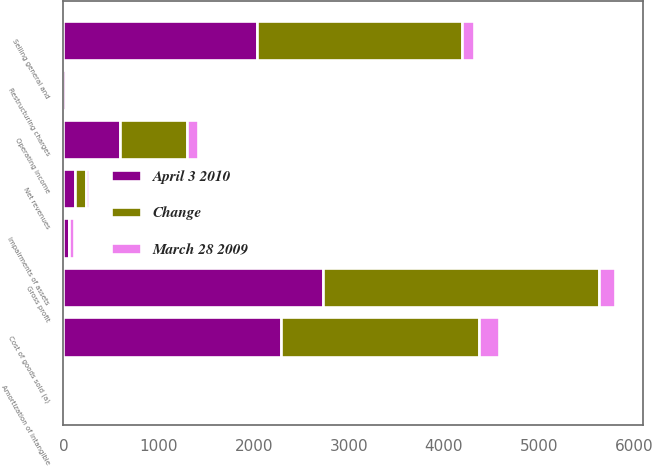<chart> <loc_0><loc_0><loc_500><loc_500><stacked_bar_chart><ecel><fcel>Net revenues<fcel>Cost of goods sold (a)<fcel>Gross profit<fcel>Selling general and<fcel>Amortization of intangible<fcel>Impairments of assets<fcel>Restructuring charges<fcel>Operating income<nl><fcel>Change<fcel>116.2<fcel>2079.8<fcel>2899.1<fcel>2157<fcel>21.7<fcel>6.6<fcel>6.9<fcel>706.9<nl><fcel>April 3 2010<fcel>116.2<fcel>2288.2<fcel>2730.7<fcel>2036<fcel>20.2<fcel>55.4<fcel>23.6<fcel>595.5<nl><fcel>March 28 2009<fcel>40<fcel>208.4<fcel>168.4<fcel>121<fcel>1.5<fcel>48.8<fcel>16.7<fcel>111.4<nl></chart> 